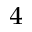Convert formula to latex. <formula><loc_0><loc_0><loc_500><loc_500>_ { 4 }</formula> 